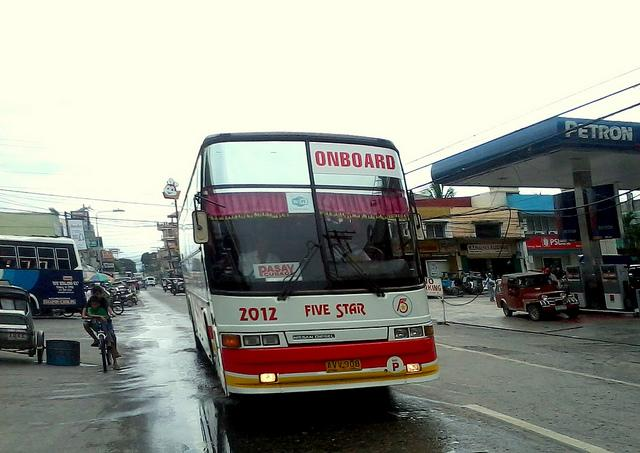Why is the red vehicle on the right stopped at the building? Please explain your reasoning. refueling. The red vehicle is parked next to a fuel pump at a "petron" station, so it is definately gassing up. 